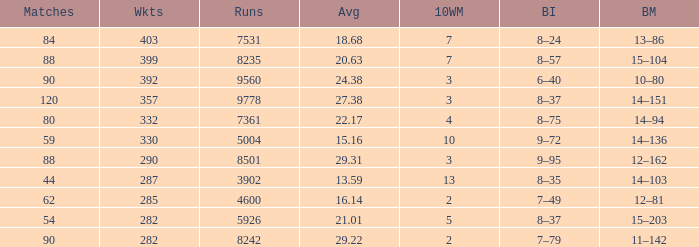What is the sum of runs that are associated with 10WM values over 13? None. 